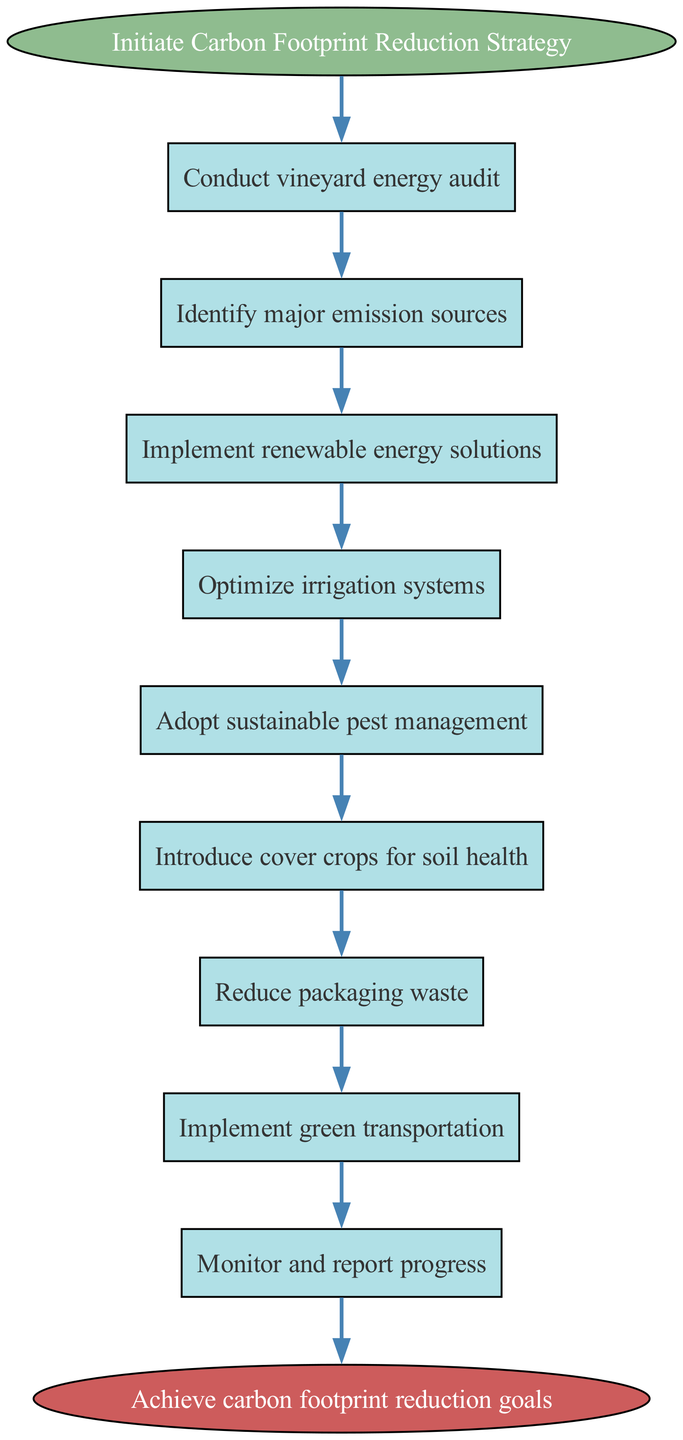What is the first step in the Carbon Footprint Reduction Strategy? The diagram starts with the node labeled "Initiate Carbon Footprint Reduction Strategy," which is the first action to be taken.
Answer: Initiate Carbon Footprint Reduction Strategy How many total steps are there in the strategy? The diagram contains a total of nine steps listed sequentially from "Conduct vineyard energy audit" to "Monitor and report progress," therefore there are nine steps before reaching the end.
Answer: Nine What is the last step in the strategy? The final node in the diagram is labeled "Achieve carbon footprint reduction goals," indicating the end result of the strategy's implementation.
Answer: Achieve carbon footprint reduction goals After implementing renewable energy solutions, what is the next step? Following the implementation of renewable energy solutions, the next step indicated in the flow is "Optimize irrigation systems."
Answer: Optimize irrigation systems What major thematic areas are addressed in the strategy? The strategy addresses areas such as energy, irrigation, pest management, soil health, packaging waste, and transportation, all contributing to sustainability efforts.
Answer: Energy, irrigation, pest management, soil health, packaging waste, transportation How many nodes are there leading to the end of the strategy? Each of the eight process steps leads directly to the end node, making a total of eight nodes that contribute to reaching the final goal.
Answer: Eight What is the purpose of conducting a vineyard energy audit? The first step, "Conduct vineyard energy audit," aims to assess energy usage and identify areas for reducing carbon emissions, thus serving as a foundational step for the strategy.
Answer: Assess energy usage What encompasses the strategy's core actions? The core actions include conducting audits, implementing renewable solutions, and adopting sustainable practices to systematically reduce carbon footprint.
Answer: Audits, renewable solutions, sustainable practices In which step is sustainable pest management adopted? Sustainable pest management is adopted in the fifth step, specifically labeled as "Adopt sustainable pest management."
Answer: Adopt sustainable pest management 